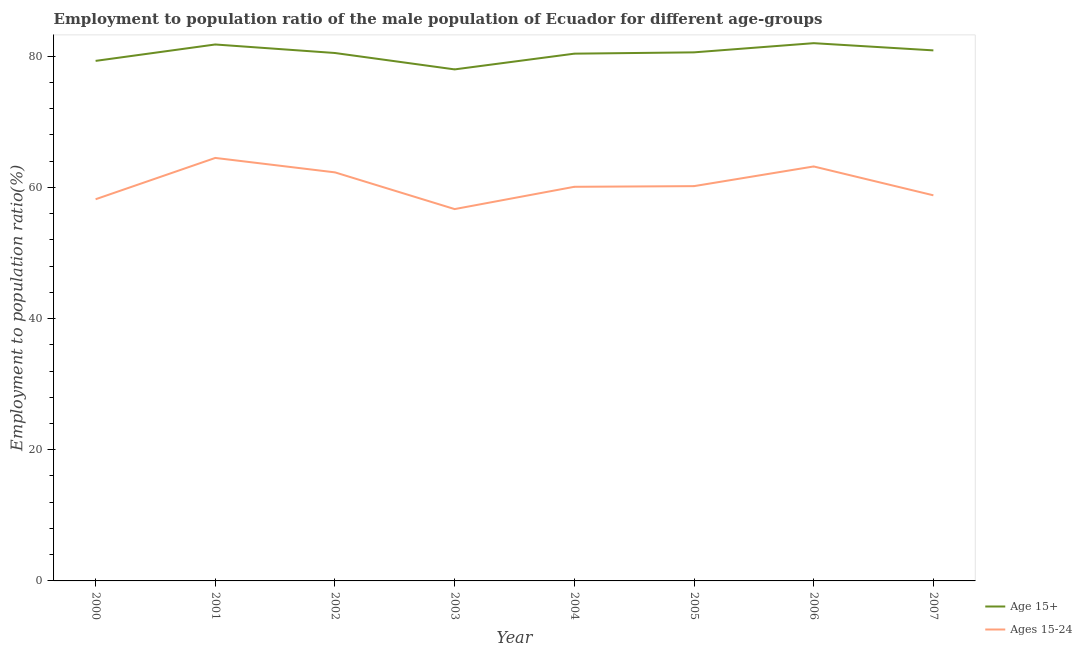Does the line corresponding to employment to population ratio(age 15+) intersect with the line corresponding to employment to population ratio(age 15-24)?
Make the answer very short. No. Is the number of lines equal to the number of legend labels?
Offer a terse response. Yes. What is the employment to population ratio(age 15-24) in 2007?
Provide a short and direct response. 58.8. Across all years, what is the maximum employment to population ratio(age 15+)?
Ensure brevity in your answer.  82. Across all years, what is the minimum employment to population ratio(age 15-24)?
Keep it short and to the point. 56.7. In which year was the employment to population ratio(age 15-24) maximum?
Keep it short and to the point. 2001. In which year was the employment to population ratio(age 15-24) minimum?
Give a very brief answer. 2003. What is the total employment to population ratio(age 15-24) in the graph?
Offer a terse response. 484. What is the difference between the employment to population ratio(age 15-24) in 2001 and that in 2006?
Provide a short and direct response. 1.3. What is the difference between the employment to population ratio(age 15+) in 2005 and the employment to population ratio(age 15-24) in 2007?
Provide a succinct answer. 21.8. What is the average employment to population ratio(age 15+) per year?
Give a very brief answer. 80.44. In the year 2001, what is the difference between the employment to population ratio(age 15+) and employment to population ratio(age 15-24)?
Ensure brevity in your answer.  17.3. What is the ratio of the employment to population ratio(age 15+) in 2002 to that in 2006?
Provide a succinct answer. 0.98. Is the employment to population ratio(age 15-24) in 2001 less than that in 2005?
Your response must be concise. No. What is the difference between the highest and the second highest employment to population ratio(age 15+)?
Make the answer very short. 0.2. What is the difference between the highest and the lowest employment to population ratio(age 15+)?
Your answer should be very brief. 4. In how many years, is the employment to population ratio(age 15+) greater than the average employment to population ratio(age 15+) taken over all years?
Give a very brief answer. 5. Is the sum of the employment to population ratio(age 15-24) in 2006 and 2007 greater than the maximum employment to population ratio(age 15+) across all years?
Ensure brevity in your answer.  Yes. Does the employment to population ratio(age 15+) monotonically increase over the years?
Your answer should be compact. No. Is the employment to population ratio(age 15+) strictly greater than the employment to population ratio(age 15-24) over the years?
Your answer should be compact. Yes. Is the employment to population ratio(age 15-24) strictly less than the employment to population ratio(age 15+) over the years?
Your answer should be very brief. Yes. Are the values on the major ticks of Y-axis written in scientific E-notation?
Your response must be concise. No. Does the graph contain any zero values?
Offer a very short reply. No. How many legend labels are there?
Keep it short and to the point. 2. How are the legend labels stacked?
Give a very brief answer. Vertical. What is the title of the graph?
Your answer should be very brief. Employment to population ratio of the male population of Ecuador for different age-groups. What is the label or title of the Y-axis?
Keep it short and to the point. Employment to population ratio(%). What is the Employment to population ratio(%) in Age 15+ in 2000?
Keep it short and to the point. 79.3. What is the Employment to population ratio(%) in Ages 15-24 in 2000?
Your answer should be compact. 58.2. What is the Employment to population ratio(%) in Age 15+ in 2001?
Offer a terse response. 81.8. What is the Employment to population ratio(%) of Ages 15-24 in 2001?
Your answer should be very brief. 64.5. What is the Employment to population ratio(%) in Age 15+ in 2002?
Your answer should be very brief. 80.5. What is the Employment to population ratio(%) in Ages 15-24 in 2002?
Keep it short and to the point. 62.3. What is the Employment to population ratio(%) of Ages 15-24 in 2003?
Make the answer very short. 56.7. What is the Employment to population ratio(%) in Age 15+ in 2004?
Give a very brief answer. 80.4. What is the Employment to population ratio(%) of Ages 15-24 in 2004?
Offer a terse response. 60.1. What is the Employment to population ratio(%) of Age 15+ in 2005?
Your answer should be compact. 80.6. What is the Employment to population ratio(%) in Ages 15-24 in 2005?
Keep it short and to the point. 60.2. What is the Employment to population ratio(%) of Age 15+ in 2006?
Provide a succinct answer. 82. What is the Employment to population ratio(%) of Ages 15-24 in 2006?
Your answer should be compact. 63.2. What is the Employment to population ratio(%) in Age 15+ in 2007?
Offer a terse response. 80.9. What is the Employment to population ratio(%) of Ages 15-24 in 2007?
Provide a succinct answer. 58.8. Across all years, what is the maximum Employment to population ratio(%) of Ages 15-24?
Offer a very short reply. 64.5. Across all years, what is the minimum Employment to population ratio(%) in Ages 15-24?
Your answer should be very brief. 56.7. What is the total Employment to population ratio(%) of Age 15+ in the graph?
Provide a succinct answer. 643.5. What is the total Employment to population ratio(%) of Ages 15-24 in the graph?
Provide a succinct answer. 484. What is the difference between the Employment to population ratio(%) in Age 15+ in 2000 and that in 2001?
Provide a short and direct response. -2.5. What is the difference between the Employment to population ratio(%) of Ages 15-24 in 2000 and that in 2002?
Give a very brief answer. -4.1. What is the difference between the Employment to population ratio(%) in Ages 15-24 in 2000 and that in 2003?
Make the answer very short. 1.5. What is the difference between the Employment to population ratio(%) in Age 15+ in 2000 and that in 2005?
Your answer should be very brief. -1.3. What is the difference between the Employment to population ratio(%) in Ages 15-24 in 2000 and that in 2005?
Give a very brief answer. -2. What is the difference between the Employment to population ratio(%) of Ages 15-24 in 2000 and that in 2006?
Provide a short and direct response. -5. What is the difference between the Employment to population ratio(%) of Ages 15-24 in 2000 and that in 2007?
Provide a short and direct response. -0.6. What is the difference between the Employment to population ratio(%) of Age 15+ in 2001 and that in 2002?
Your answer should be compact. 1.3. What is the difference between the Employment to population ratio(%) of Ages 15-24 in 2001 and that in 2002?
Give a very brief answer. 2.2. What is the difference between the Employment to population ratio(%) in Ages 15-24 in 2001 and that in 2003?
Your answer should be very brief. 7.8. What is the difference between the Employment to population ratio(%) in Age 15+ in 2001 and that in 2004?
Keep it short and to the point. 1.4. What is the difference between the Employment to population ratio(%) in Ages 15-24 in 2001 and that in 2007?
Your answer should be compact. 5.7. What is the difference between the Employment to population ratio(%) of Age 15+ in 2002 and that in 2003?
Offer a terse response. 2.5. What is the difference between the Employment to population ratio(%) in Age 15+ in 2002 and that in 2004?
Keep it short and to the point. 0.1. What is the difference between the Employment to population ratio(%) of Ages 15-24 in 2002 and that in 2004?
Offer a very short reply. 2.2. What is the difference between the Employment to population ratio(%) in Age 15+ in 2002 and that in 2005?
Ensure brevity in your answer.  -0.1. What is the difference between the Employment to population ratio(%) of Ages 15-24 in 2002 and that in 2006?
Your answer should be very brief. -0.9. What is the difference between the Employment to population ratio(%) in Age 15+ in 2002 and that in 2007?
Provide a succinct answer. -0.4. What is the difference between the Employment to population ratio(%) in Ages 15-24 in 2003 and that in 2004?
Provide a short and direct response. -3.4. What is the difference between the Employment to population ratio(%) in Age 15+ in 2003 and that in 2006?
Provide a short and direct response. -4. What is the difference between the Employment to population ratio(%) of Ages 15-24 in 2003 and that in 2006?
Ensure brevity in your answer.  -6.5. What is the difference between the Employment to population ratio(%) of Ages 15-24 in 2003 and that in 2007?
Offer a very short reply. -2.1. What is the difference between the Employment to population ratio(%) in Ages 15-24 in 2004 and that in 2006?
Your answer should be compact. -3.1. What is the difference between the Employment to population ratio(%) of Ages 15-24 in 2004 and that in 2007?
Offer a very short reply. 1.3. What is the difference between the Employment to population ratio(%) in Age 15+ in 2005 and that in 2006?
Provide a short and direct response. -1.4. What is the difference between the Employment to population ratio(%) of Ages 15-24 in 2005 and that in 2006?
Your answer should be very brief. -3. What is the difference between the Employment to population ratio(%) in Ages 15-24 in 2005 and that in 2007?
Ensure brevity in your answer.  1.4. What is the difference between the Employment to population ratio(%) in Age 15+ in 2000 and the Employment to population ratio(%) in Ages 15-24 in 2001?
Offer a terse response. 14.8. What is the difference between the Employment to population ratio(%) of Age 15+ in 2000 and the Employment to population ratio(%) of Ages 15-24 in 2002?
Your answer should be very brief. 17. What is the difference between the Employment to population ratio(%) in Age 15+ in 2000 and the Employment to population ratio(%) in Ages 15-24 in 2003?
Your answer should be compact. 22.6. What is the difference between the Employment to population ratio(%) of Age 15+ in 2000 and the Employment to population ratio(%) of Ages 15-24 in 2004?
Keep it short and to the point. 19.2. What is the difference between the Employment to population ratio(%) of Age 15+ in 2000 and the Employment to population ratio(%) of Ages 15-24 in 2006?
Offer a very short reply. 16.1. What is the difference between the Employment to population ratio(%) of Age 15+ in 2000 and the Employment to population ratio(%) of Ages 15-24 in 2007?
Provide a succinct answer. 20.5. What is the difference between the Employment to population ratio(%) of Age 15+ in 2001 and the Employment to population ratio(%) of Ages 15-24 in 2002?
Ensure brevity in your answer.  19.5. What is the difference between the Employment to population ratio(%) of Age 15+ in 2001 and the Employment to population ratio(%) of Ages 15-24 in 2003?
Your answer should be very brief. 25.1. What is the difference between the Employment to population ratio(%) in Age 15+ in 2001 and the Employment to population ratio(%) in Ages 15-24 in 2004?
Provide a succinct answer. 21.7. What is the difference between the Employment to population ratio(%) of Age 15+ in 2001 and the Employment to population ratio(%) of Ages 15-24 in 2005?
Make the answer very short. 21.6. What is the difference between the Employment to population ratio(%) of Age 15+ in 2001 and the Employment to population ratio(%) of Ages 15-24 in 2007?
Your answer should be compact. 23. What is the difference between the Employment to population ratio(%) of Age 15+ in 2002 and the Employment to population ratio(%) of Ages 15-24 in 2003?
Your answer should be compact. 23.8. What is the difference between the Employment to population ratio(%) of Age 15+ in 2002 and the Employment to population ratio(%) of Ages 15-24 in 2004?
Your answer should be compact. 20.4. What is the difference between the Employment to population ratio(%) of Age 15+ in 2002 and the Employment to population ratio(%) of Ages 15-24 in 2005?
Give a very brief answer. 20.3. What is the difference between the Employment to population ratio(%) in Age 15+ in 2002 and the Employment to population ratio(%) in Ages 15-24 in 2007?
Keep it short and to the point. 21.7. What is the difference between the Employment to population ratio(%) in Age 15+ in 2003 and the Employment to population ratio(%) in Ages 15-24 in 2004?
Offer a very short reply. 17.9. What is the difference between the Employment to population ratio(%) in Age 15+ in 2003 and the Employment to population ratio(%) in Ages 15-24 in 2006?
Offer a very short reply. 14.8. What is the difference between the Employment to population ratio(%) in Age 15+ in 2004 and the Employment to population ratio(%) in Ages 15-24 in 2005?
Keep it short and to the point. 20.2. What is the difference between the Employment to population ratio(%) in Age 15+ in 2004 and the Employment to population ratio(%) in Ages 15-24 in 2007?
Offer a terse response. 21.6. What is the difference between the Employment to population ratio(%) in Age 15+ in 2005 and the Employment to population ratio(%) in Ages 15-24 in 2007?
Offer a very short reply. 21.8. What is the difference between the Employment to population ratio(%) in Age 15+ in 2006 and the Employment to population ratio(%) in Ages 15-24 in 2007?
Your response must be concise. 23.2. What is the average Employment to population ratio(%) of Age 15+ per year?
Offer a very short reply. 80.44. What is the average Employment to population ratio(%) in Ages 15-24 per year?
Give a very brief answer. 60.5. In the year 2000, what is the difference between the Employment to population ratio(%) in Age 15+ and Employment to population ratio(%) in Ages 15-24?
Provide a succinct answer. 21.1. In the year 2002, what is the difference between the Employment to population ratio(%) in Age 15+ and Employment to population ratio(%) in Ages 15-24?
Your response must be concise. 18.2. In the year 2003, what is the difference between the Employment to population ratio(%) in Age 15+ and Employment to population ratio(%) in Ages 15-24?
Provide a short and direct response. 21.3. In the year 2004, what is the difference between the Employment to population ratio(%) in Age 15+ and Employment to population ratio(%) in Ages 15-24?
Your answer should be compact. 20.3. In the year 2005, what is the difference between the Employment to population ratio(%) in Age 15+ and Employment to population ratio(%) in Ages 15-24?
Ensure brevity in your answer.  20.4. In the year 2006, what is the difference between the Employment to population ratio(%) in Age 15+ and Employment to population ratio(%) in Ages 15-24?
Ensure brevity in your answer.  18.8. In the year 2007, what is the difference between the Employment to population ratio(%) in Age 15+ and Employment to population ratio(%) in Ages 15-24?
Offer a terse response. 22.1. What is the ratio of the Employment to population ratio(%) of Age 15+ in 2000 to that in 2001?
Your answer should be very brief. 0.97. What is the ratio of the Employment to population ratio(%) in Ages 15-24 in 2000 to that in 2001?
Offer a very short reply. 0.9. What is the ratio of the Employment to population ratio(%) of Age 15+ in 2000 to that in 2002?
Offer a terse response. 0.99. What is the ratio of the Employment to population ratio(%) in Ages 15-24 in 2000 to that in 2002?
Offer a terse response. 0.93. What is the ratio of the Employment to population ratio(%) of Age 15+ in 2000 to that in 2003?
Make the answer very short. 1.02. What is the ratio of the Employment to population ratio(%) of Ages 15-24 in 2000 to that in 2003?
Ensure brevity in your answer.  1.03. What is the ratio of the Employment to population ratio(%) of Age 15+ in 2000 to that in 2004?
Your answer should be compact. 0.99. What is the ratio of the Employment to population ratio(%) of Ages 15-24 in 2000 to that in 2004?
Your answer should be very brief. 0.97. What is the ratio of the Employment to population ratio(%) of Age 15+ in 2000 to that in 2005?
Ensure brevity in your answer.  0.98. What is the ratio of the Employment to population ratio(%) in Ages 15-24 in 2000 to that in 2005?
Make the answer very short. 0.97. What is the ratio of the Employment to population ratio(%) of Age 15+ in 2000 to that in 2006?
Your response must be concise. 0.97. What is the ratio of the Employment to population ratio(%) of Ages 15-24 in 2000 to that in 2006?
Make the answer very short. 0.92. What is the ratio of the Employment to population ratio(%) in Age 15+ in 2000 to that in 2007?
Provide a succinct answer. 0.98. What is the ratio of the Employment to population ratio(%) of Age 15+ in 2001 to that in 2002?
Offer a very short reply. 1.02. What is the ratio of the Employment to population ratio(%) of Ages 15-24 in 2001 to that in 2002?
Offer a very short reply. 1.04. What is the ratio of the Employment to population ratio(%) in Age 15+ in 2001 to that in 2003?
Your answer should be compact. 1.05. What is the ratio of the Employment to population ratio(%) in Ages 15-24 in 2001 to that in 2003?
Give a very brief answer. 1.14. What is the ratio of the Employment to population ratio(%) in Age 15+ in 2001 to that in 2004?
Give a very brief answer. 1.02. What is the ratio of the Employment to population ratio(%) in Ages 15-24 in 2001 to that in 2004?
Your response must be concise. 1.07. What is the ratio of the Employment to population ratio(%) in Age 15+ in 2001 to that in 2005?
Offer a terse response. 1.01. What is the ratio of the Employment to population ratio(%) in Ages 15-24 in 2001 to that in 2005?
Give a very brief answer. 1.07. What is the ratio of the Employment to population ratio(%) of Age 15+ in 2001 to that in 2006?
Your answer should be compact. 1. What is the ratio of the Employment to population ratio(%) of Ages 15-24 in 2001 to that in 2006?
Make the answer very short. 1.02. What is the ratio of the Employment to population ratio(%) in Age 15+ in 2001 to that in 2007?
Your answer should be compact. 1.01. What is the ratio of the Employment to population ratio(%) of Ages 15-24 in 2001 to that in 2007?
Your response must be concise. 1.1. What is the ratio of the Employment to population ratio(%) of Age 15+ in 2002 to that in 2003?
Provide a short and direct response. 1.03. What is the ratio of the Employment to population ratio(%) of Ages 15-24 in 2002 to that in 2003?
Your answer should be very brief. 1.1. What is the ratio of the Employment to population ratio(%) in Ages 15-24 in 2002 to that in 2004?
Provide a short and direct response. 1.04. What is the ratio of the Employment to population ratio(%) of Ages 15-24 in 2002 to that in 2005?
Provide a succinct answer. 1.03. What is the ratio of the Employment to population ratio(%) in Age 15+ in 2002 to that in 2006?
Your answer should be very brief. 0.98. What is the ratio of the Employment to population ratio(%) of Ages 15-24 in 2002 to that in 2006?
Give a very brief answer. 0.99. What is the ratio of the Employment to population ratio(%) in Age 15+ in 2002 to that in 2007?
Your answer should be very brief. 1. What is the ratio of the Employment to population ratio(%) in Ages 15-24 in 2002 to that in 2007?
Your answer should be very brief. 1.06. What is the ratio of the Employment to population ratio(%) in Age 15+ in 2003 to that in 2004?
Your answer should be compact. 0.97. What is the ratio of the Employment to population ratio(%) in Ages 15-24 in 2003 to that in 2004?
Give a very brief answer. 0.94. What is the ratio of the Employment to population ratio(%) in Age 15+ in 2003 to that in 2005?
Provide a succinct answer. 0.97. What is the ratio of the Employment to population ratio(%) of Ages 15-24 in 2003 to that in 2005?
Your answer should be very brief. 0.94. What is the ratio of the Employment to population ratio(%) in Age 15+ in 2003 to that in 2006?
Give a very brief answer. 0.95. What is the ratio of the Employment to population ratio(%) of Ages 15-24 in 2003 to that in 2006?
Offer a terse response. 0.9. What is the ratio of the Employment to population ratio(%) of Age 15+ in 2003 to that in 2007?
Your answer should be very brief. 0.96. What is the ratio of the Employment to population ratio(%) in Age 15+ in 2004 to that in 2006?
Make the answer very short. 0.98. What is the ratio of the Employment to population ratio(%) in Ages 15-24 in 2004 to that in 2006?
Your response must be concise. 0.95. What is the ratio of the Employment to population ratio(%) of Age 15+ in 2004 to that in 2007?
Give a very brief answer. 0.99. What is the ratio of the Employment to population ratio(%) in Ages 15-24 in 2004 to that in 2007?
Offer a terse response. 1.02. What is the ratio of the Employment to population ratio(%) in Age 15+ in 2005 to that in 2006?
Provide a succinct answer. 0.98. What is the ratio of the Employment to population ratio(%) in Ages 15-24 in 2005 to that in 2006?
Your answer should be compact. 0.95. What is the ratio of the Employment to population ratio(%) of Ages 15-24 in 2005 to that in 2007?
Give a very brief answer. 1.02. What is the ratio of the Employment to population ratio(%) of Age 15+ in 2006 to that in 2007?
Keep it short and to the point. 1.01. What is the ratio of the Employment to population ratio(%) of Ages 15-24 in 2006 to that in 2007?
Provide a short and direct response. 1.07. 